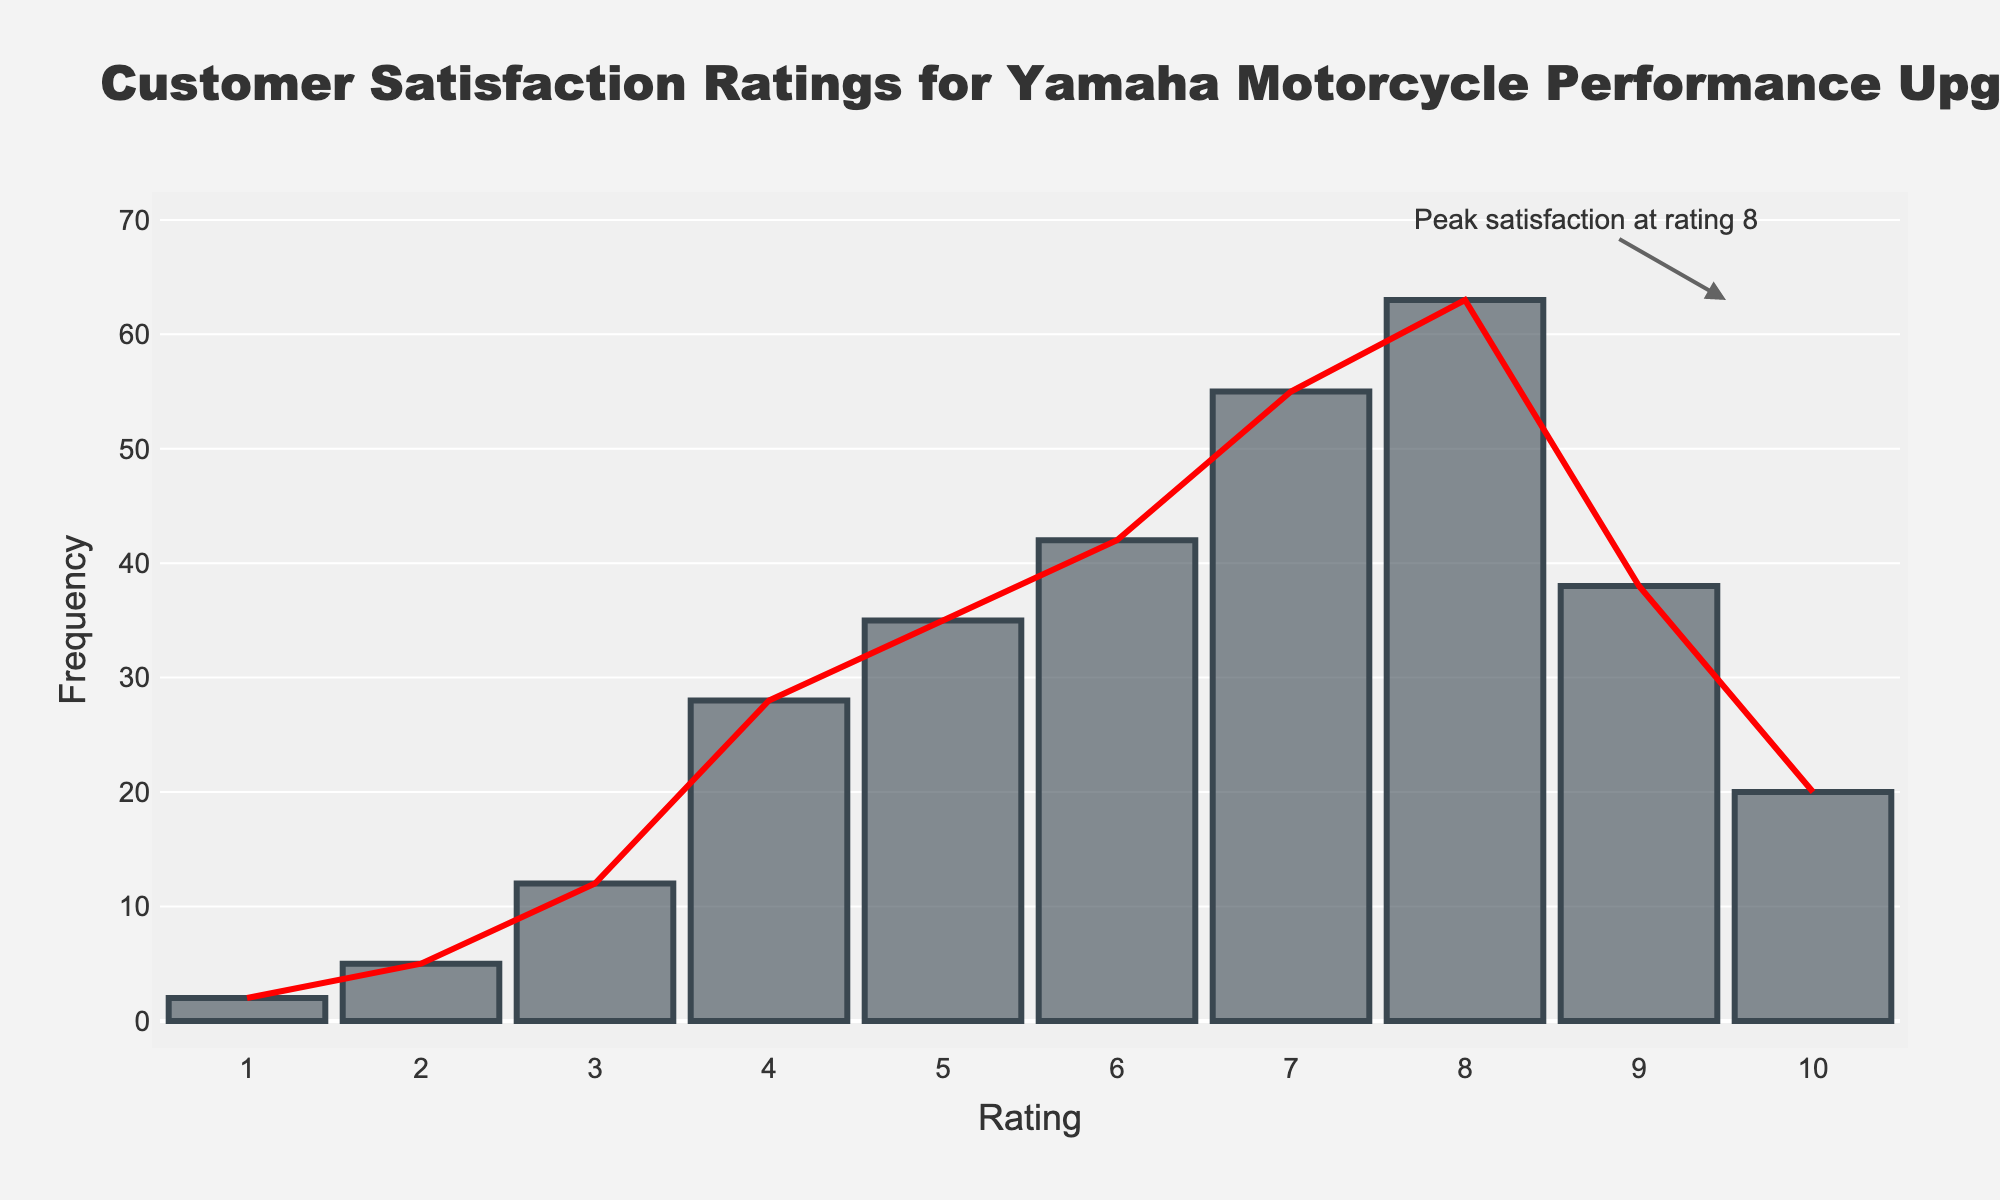What is the title of the figure? The title is located at the top of the figure and helps indicate what the data is about. The title reads "Customer Satisfaction Ratings for Yamaha Motorcycle Performance Upgrades".
Answer: Customer Satisfaction Ratings for Yamaha Motorcycle Performance Upgrades What does the x-axis represent? The x-axis is labeled with the term "Rating", which indicates that it represents the customer satisfaction ratings.
Answer: Rating What does the y-axis represent? The y-axis is labeled with the term "Frequency", indicating it represents the number of customers who gave each rating.
Answer: Frequency What is the most common customer satisfaction rating? The most common rating is represented by the tallest bar on the histogram. The highest bar is at the rating of 8.
Answer: 8 What rating has the fewest responses? The shortest bar represents the rating with the fewest responses, which is at the rating of 1.
Answer: 1 Which rating(s) have a frequency higher than 50? By inspecting the y-axis values, we can see that there are bars above the 50 mark for ratings 7 and 8.
Answer: 7 and 8 What is the total frequency of ratings below 5? We sum the frequencies of all ratings below 5: 2 (rating 1) + 5 (rating 2) + 12 (rating 3) + 28 (rating 4) = 47.
Answer: 47 Is the frequency of rating 10 higher or lower than that of rating 9? By comparing the heights of the two bars, the bar for rating 10 is shorter than the bar for rating 9, indicating a lower frequency.
Answer: Lower At what rating does the red trend line peak? The peak of the red trend line aligns with the highest bar, which is at rating 8.
Answer: 8 How many ratings have a frequency greater than or equal to 30? By visually inspecting the bars, ratings 4, 5, 6, 7, 8, and 9 have frequencies of 28, 35, 42, 55, 63, and 38 respectively. Summing them up, we get 6 ratings with frequencies greater than or equal to 30.
Answer: 6 